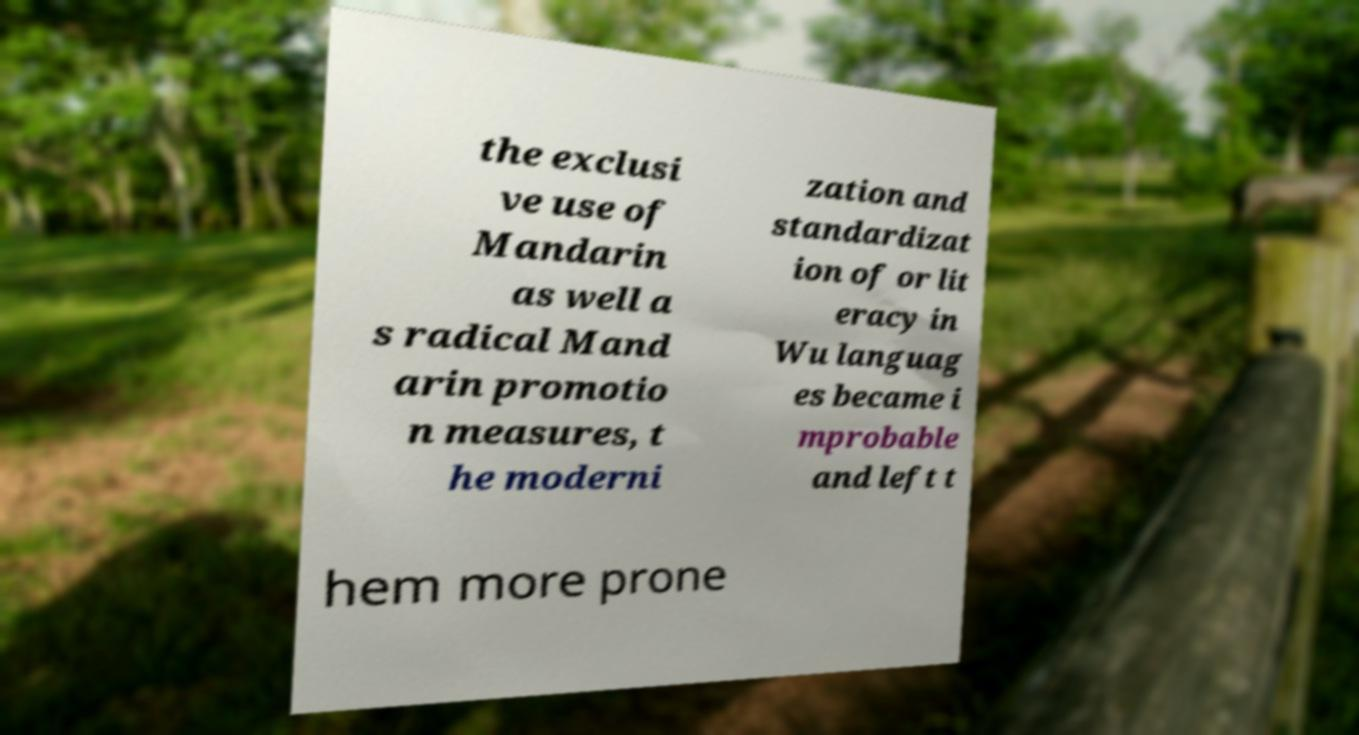Please read and relay the text visible in this image. What does it say? the exclusi ve use of Mandarin as well a s radical Mand arin promotio n measures, t he moderni zation and standardizat ion of or lit eracy in Wu languag es became i mprobable and left t hem more prone 